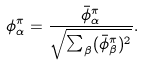<formula> <loc_0><loc_0><loc_500><loc_500>\phi ^ { \pi } _ { \alpha } = \frac { \bar { \phi } ^ { \pi } _ { \alpha } } { \sqrt { \sum _ { \beta } ( \bar { \phi } ^ { \pi } _ { \beta } ) ^ { 2 } } } .</formula> 